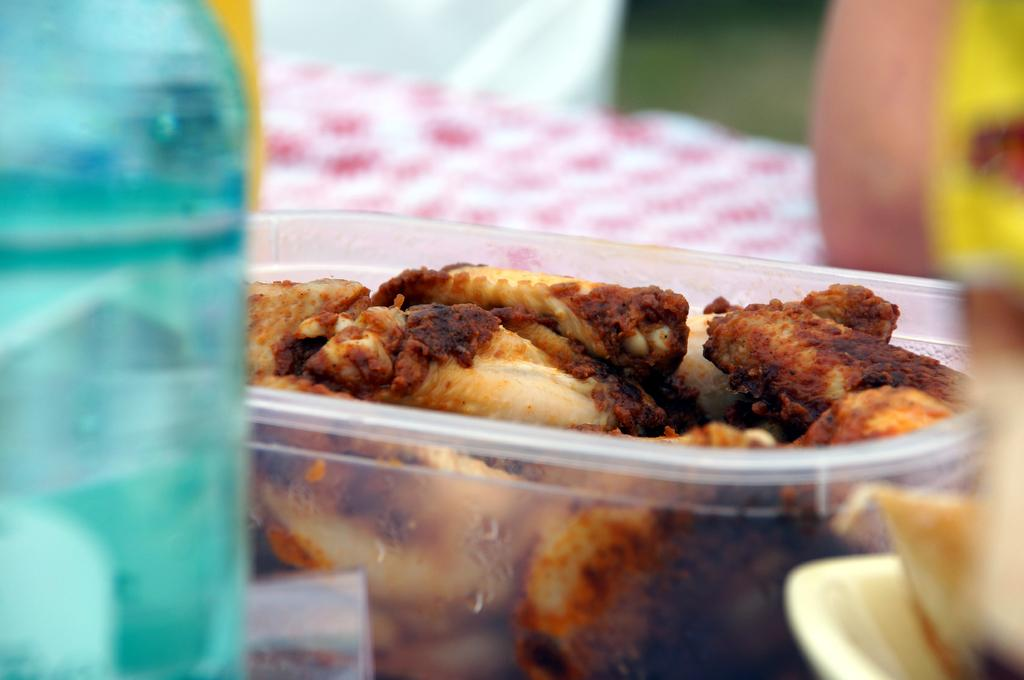What is contained within the box in the image? There are food items in a box in the image. What other object is visible beside the box? There is a bottle beside the box. What can be seen behind the box in the image? There is a cloth behind the box. How would you describe the background of the image? The background of the image is blurred. Is there a pump visible in the image? No, there is no pump present in the image. Can you see a flame in the image? No, there is no flame present in the image. 